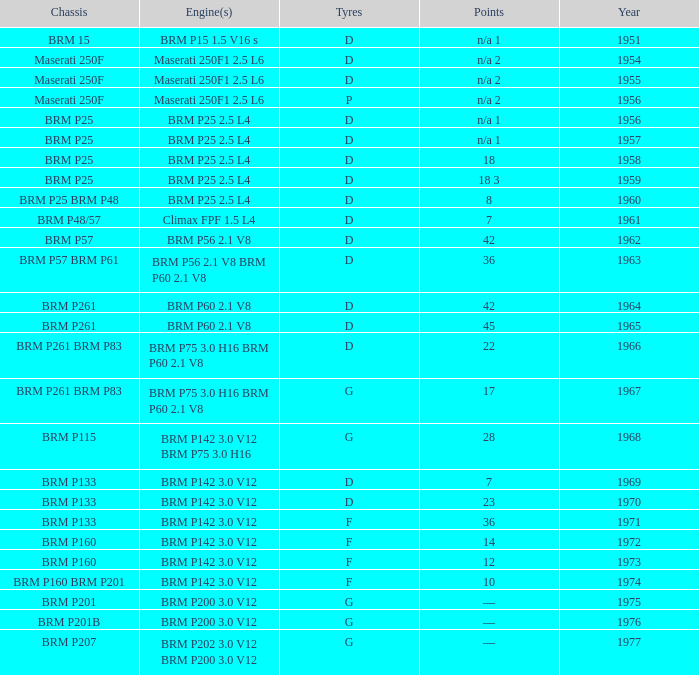Name the chassis for 1970 and tyres of d BRM P133. 